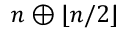<formula> <loc_0><loc_0><loc_500><loc_500>n \oplus \lfloor n / 2 \rfloor</formula> 